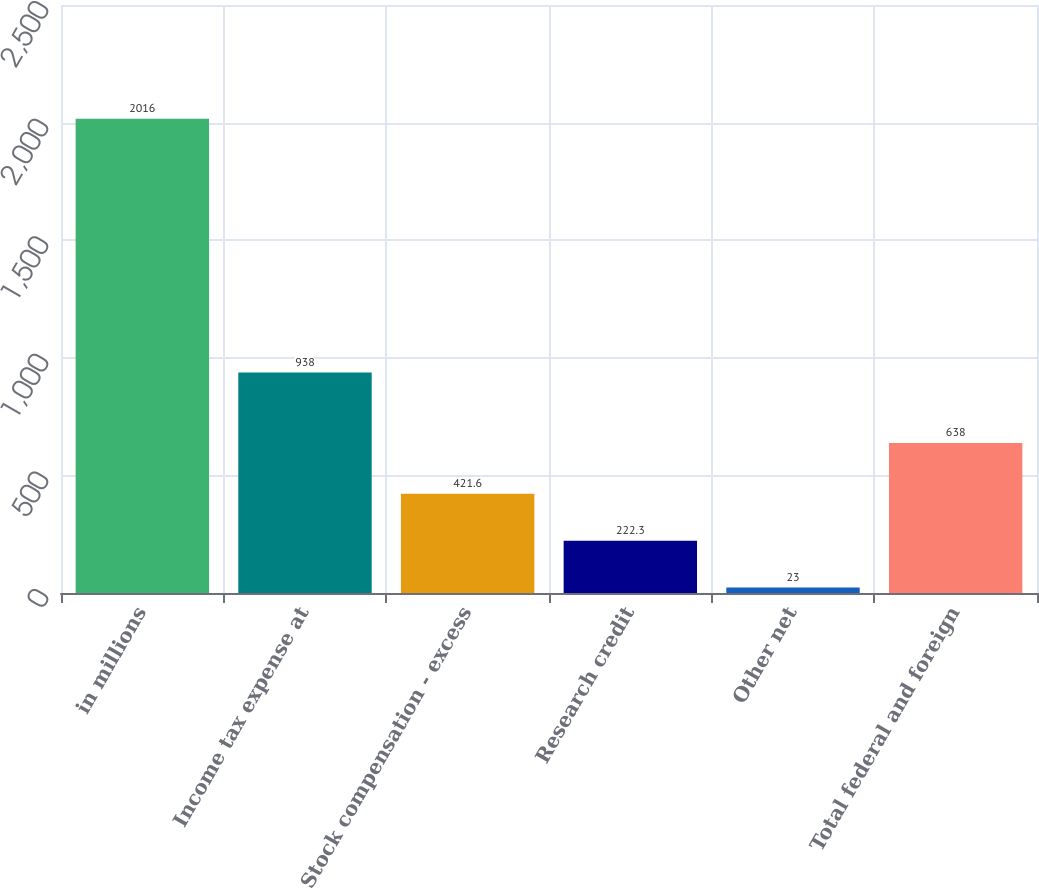Convert chart. <chart><loc_0><loc_0><loc_500><loc_500><bar_chart><fcel>in millions<fcel>Income tax expense at<fcel>Stock compensation - excess<fcel>Research credit<fcel>Other net<fcel>Total federal and foreign<nl><fcel>2016<fcel>938<fcel>421.6<fcel>222.3<fcel>23<fcel>638<nl></chart> 